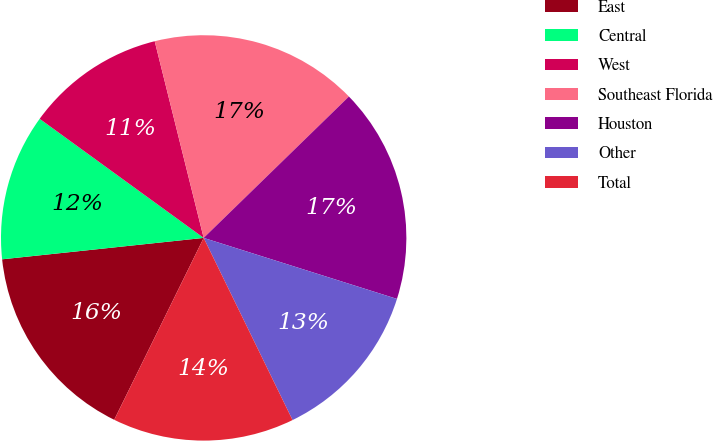Convert chart to OTSL. <chart><loc_0><loc_0><loc_500><loc_500><pie_chart><fcel>East<fcel>Central<fcel>West<fcel>Southeast Florida<fcel>Houston<fcel>Other<fcel>Total<nl><fcel>16.04%<fcel>11.68%<fcel>11.12%<fcel>16.6%<fcel>17.15%<fcel>12.91%<fcel>14.5%<nl></chart> 